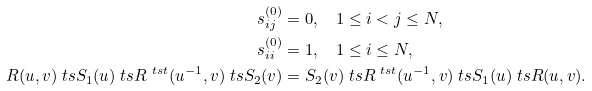<formula> <loc_0><loc_0><loc_500><loc_500>s _ { i j } ^ { ( 0 ) } & = 0 , \quad 1 \leq i < j \leq N , \\ s _ { i i } ^ { ( 0 ) } & = 1 , \quad 1 \leq i \leq N , \\ R ( u , v ) \ t s S _ { 1 } ( u ) \ t s R ^ { \ t s t } ( u ^ { - 1 } , v ) \ t s S _ { 2 } ( v ) & = S _ { 2 } ( v ) \ t s R ^ { \ t s t } ( u ^ { - 1 } , v ) \ t s S _ { 1 } ( u ) \ t s R ( u , v ) .</formula> 